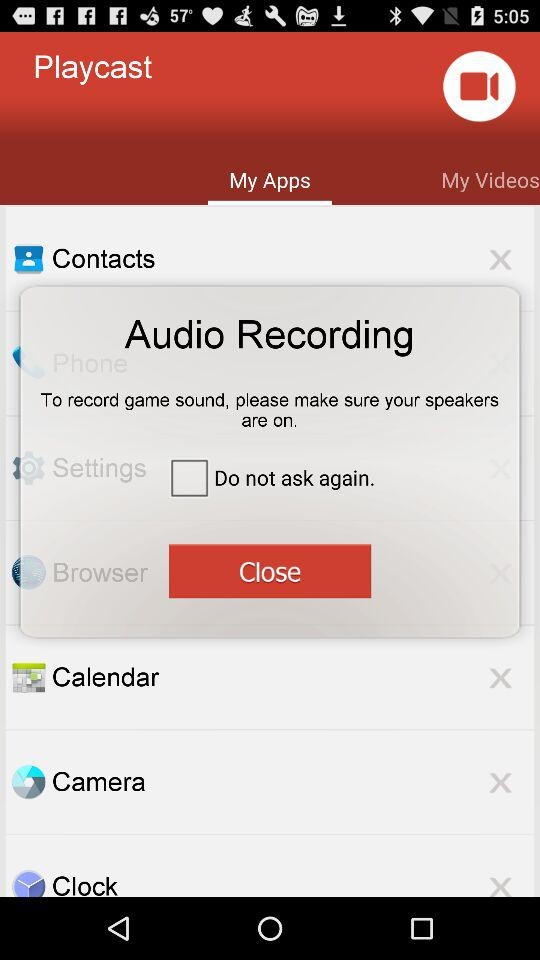Which tab is selected? The selected tab is "My Apps". 